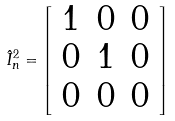Convert formula to latex. <formula><loc_0><loc_0><loc_500><loc_500>\hat { I } _ { n } ^ { 2 } = \left [ \begin{array} { c c c } 1 & 0 & 0 \\ 0 & 1 & 0 \\ 0 & 0 & 0 \\ \end{array} \right ]</formula> 